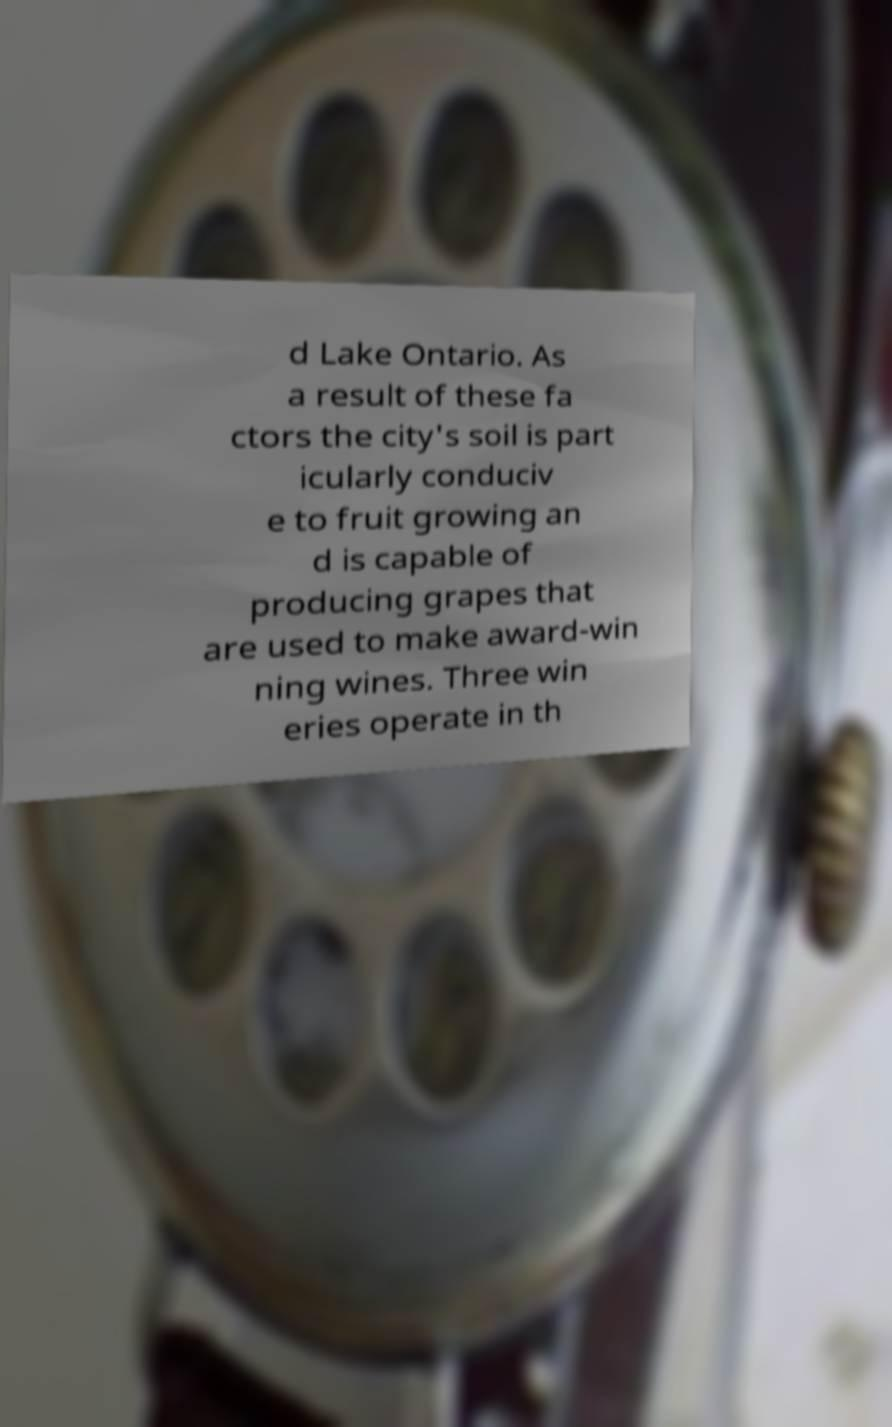Please read and relay the text visible in this image. What does it say? d Lake Ontario. As a result of these fa ctors the city's soil is part icularly conduciv e to fruit growing an d is capable of producing grapes that are used to make award-win ning wines. Three win eries operate in th 